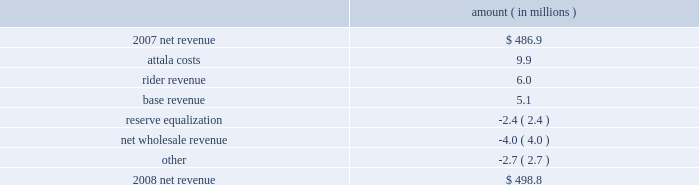Entergy mississippi , inc .
Management's financial discussion and analysis results of operations net income 2008 compared to 2007 net income decreased $ 12.4 million primarily due to higher other operation and maintenance expenses , lower other income , and higher depreciation and amortization expenses , partially offset by higher net revenue .
2007 compared to 2006 net income increased $ 19.8 million primarily due to higher net revenue , lower other operation and maintenance expenses , higher other income , and lower interest expense , partially offset by higher depreciation and amortization expenses .
Net revenue 2008 compared to 2007 net revenue consists of operating revenues net of : 1 ) fuel , fuel-related expenses , and gas purchased for resale , 2 ) purchased power expenses , and 3 ) other regulatory charges .
Following is an analysis of the change in net revenue comparing 2008 to 2007 .
Amount ( in millions ) .
The attala costs variance is primarily due to an increase in the attala power plant costs that are recovered through the power management rider .
The net income effect of this recovery in limited to a portion representing an allowed return on equity with the remainder offset by attala power plant costs in other operation and maintenance expenses , depreciation expenses , and taxes other than income taxes .
The recovery of attala power plant costs is discussed further in "liquidity and capital resources - uses of capital" below .
The rider revenue variance is the result of a storm damage rider that became effective in october 2007 .
The establishment of this rider results in an increase in rider revenue and a corresponding increase in other operation and maintenance expense for the storm reserve with no effect on net income .
The base revenue variance is primarily due to a formula rate plan increase effective july 2007 .
The formula rate plan filing is discussed further in "state and local rate regulation" below .
The reserve equalization variance is primarily due to changes in the entergy system generation mix compared to the same period in 2007. .
What is the net difference in net revenue in 2008 compare to 2007? 
Computations: (498.8 - 486.9)
Answer: 11.9. 